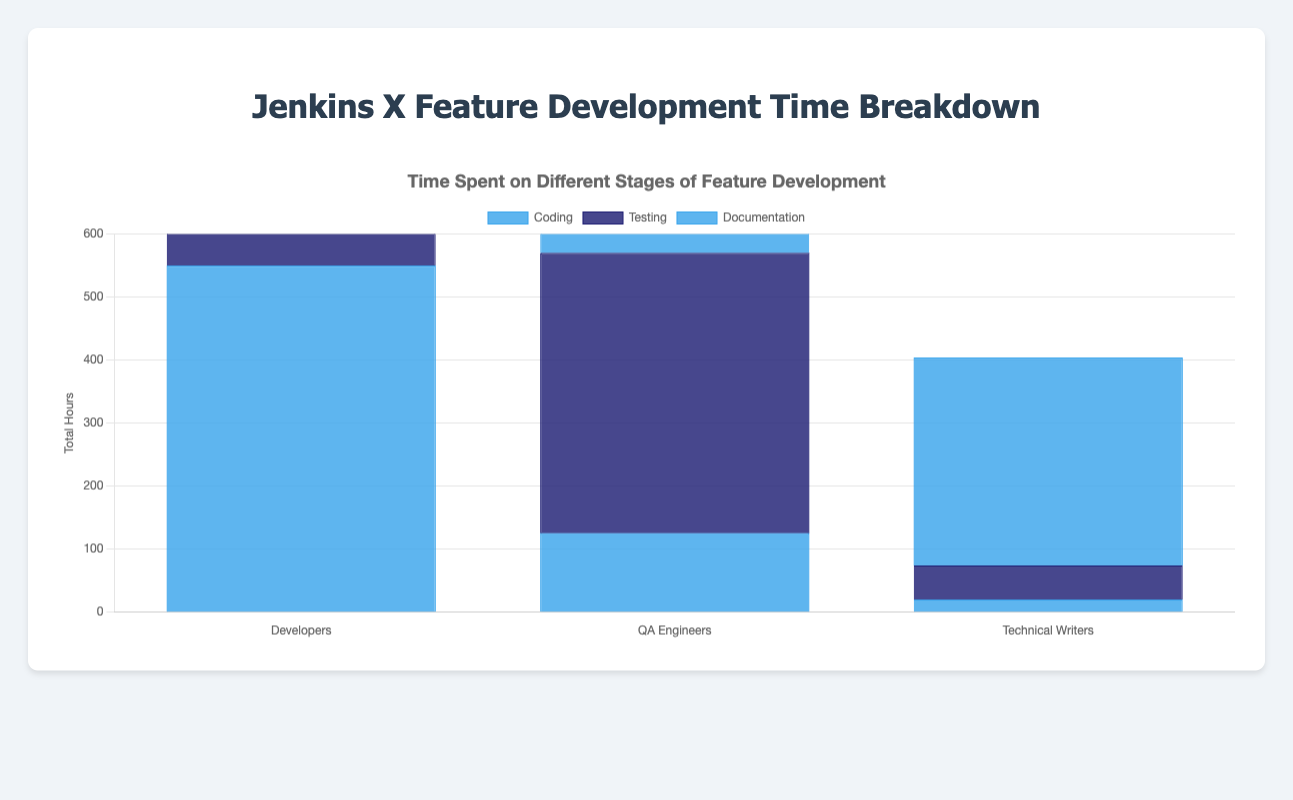Which team role spent the most time on testing across all weeks? To find the team role that spent the most time on testing, sum the testing hours for all weeks for each role. Developers: 20 + 25 + 30 + 22 = 97 hours, QA Engineers: 100 + 120 + 110 + 115 = 445 hours, Technical Writers: 15 + 12 + 14 + 13 = 54 hours. QA Engineers spent the most time on testing.
Answer: QA Engineers How does the total time spent on documentation by Technical Writers compare to that of Developers? First, sum the total time spent on documentation for both roles. Developers: 10 + 8 + 12 + 9 = 39 hours, Technical Writers: 80 + 75 + 90 + 85 = 330 hours. Compare the two sums: 330 > 39. Therefore, Technical Writers spent significantly more time on documentation.
Answer: Technical Writers spent more time What is the average time spent on coding by Developers per week? Sum the coding hours for Developers across all weeks and divide by the number of weeks. Total coding time for Developers: 120 + 140 + 160 + 130 = 550 hours over 4 weeks. Average: 550 / 4 = 137.5 hours per week.
Answer: 137.5 hours Which team role has the smallest total time spent on any stage of development? Calculate the total time spent on each stage for each role and compare the smallest values. Developers: Coding: 550, Testing: 97, Documentation: 39. QA Engineers: Coding: 125, Testing: 445, Documentation: 55. Technical Writers: Coding: 20, Testing: 54, Documentation: 330. The smallest value is Technical Writers on Coding (20 hours).
Answer: Technical Writers on Coding How much more time did QA Engineers spend on testing than on coding during week 1? Subtract the time QA Engineers spent on coding during week 1 from the time spent on testing. Testing: 100 hours, Coding: 30 hours. Difference: 100 - 30 = 70 hours.
Answer: 70 hours What is the total time spent by all team roles on documentation in week 3? Sum the documentation times for all team roles in week 3. Developers: 12 hours, QA Engineers: 18 hours, Technical Writers: 90 hours. Total: 12 + 18 + 90 = 120 hours.
Answer: 120 hours What is the percentage of time spent by Developers on testing compared to their total time spent on all activities? First, calculate the total time spent by Developers on all activities: 550 (coding) + 97 (testing) + 39 (documentation) = 686 hours. Then the percentage: (97 / 686) * 100 = 14.14%.
Answer: 14.14% Which stage has the highest total time across all team roles? Sum the time spent on each stage by all team roles to determine which is the highest. Coding: Developers (550) + QA Engineers (125) + Technical Writers (20) = 695 hours. Testing: Developers (97) + QA Engineers (445) + Technical Writers (54) = 596 hours. Documentation: Developers (39) + QA Engineers (55) + Technical Writers (330) = 424 hours. Coding has the highest total time.
Answer: Coding 